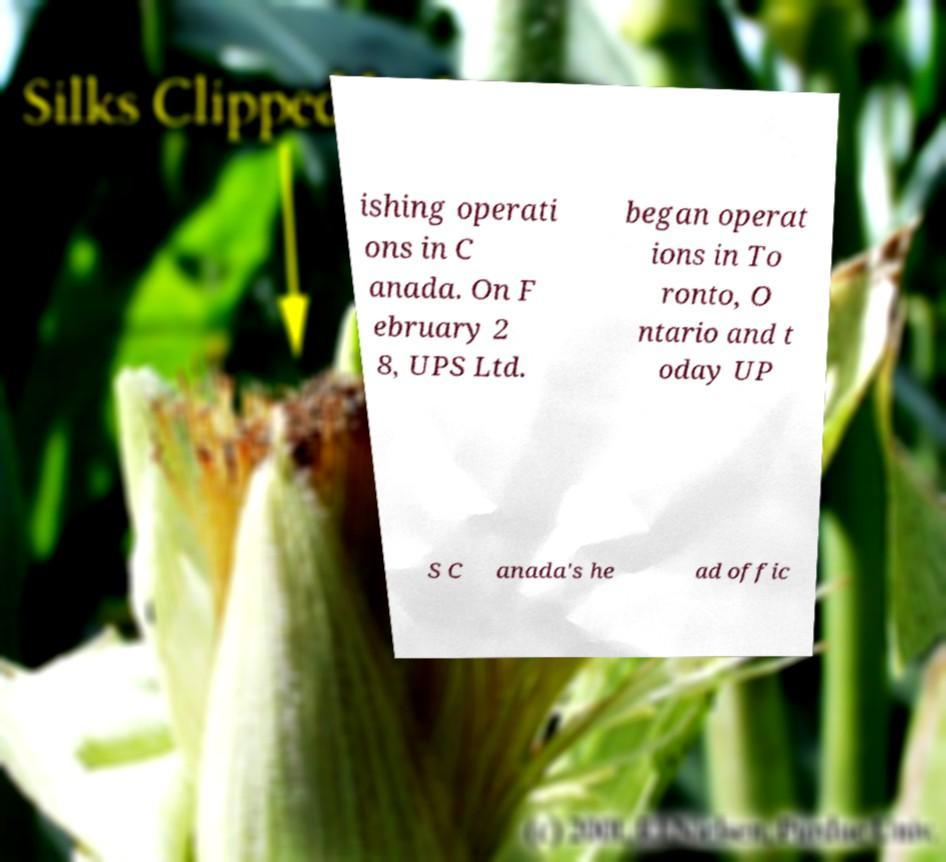Could you assist in decoding the text presented in this image and type it out clearly? ishing operati ons in C anada. On F ebruary 2 8, UPS Ltd. began operat ions in To ronto, O ntario and t oday UP S C anada's he ad offic 